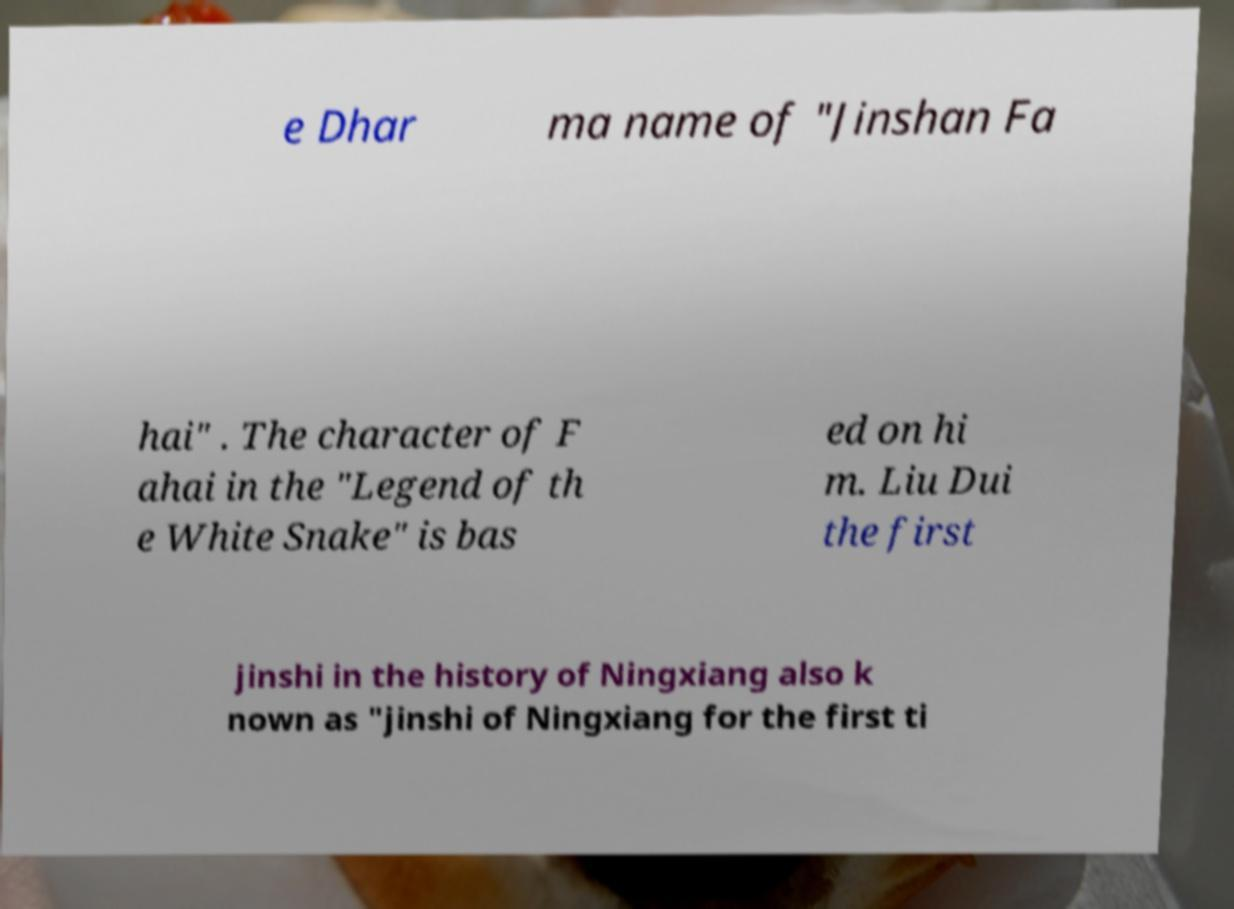Please identify and transcribe the text found in this image. e Dhar ma name of "Jinshan Fa hai" . The character of F ahai in the "Legend of th e White Snake" is bas ed on hi m. Liu Dui the first jinshi in the history of Ningxiang also k nown as "jinshi of Ningxiang for the first ti 